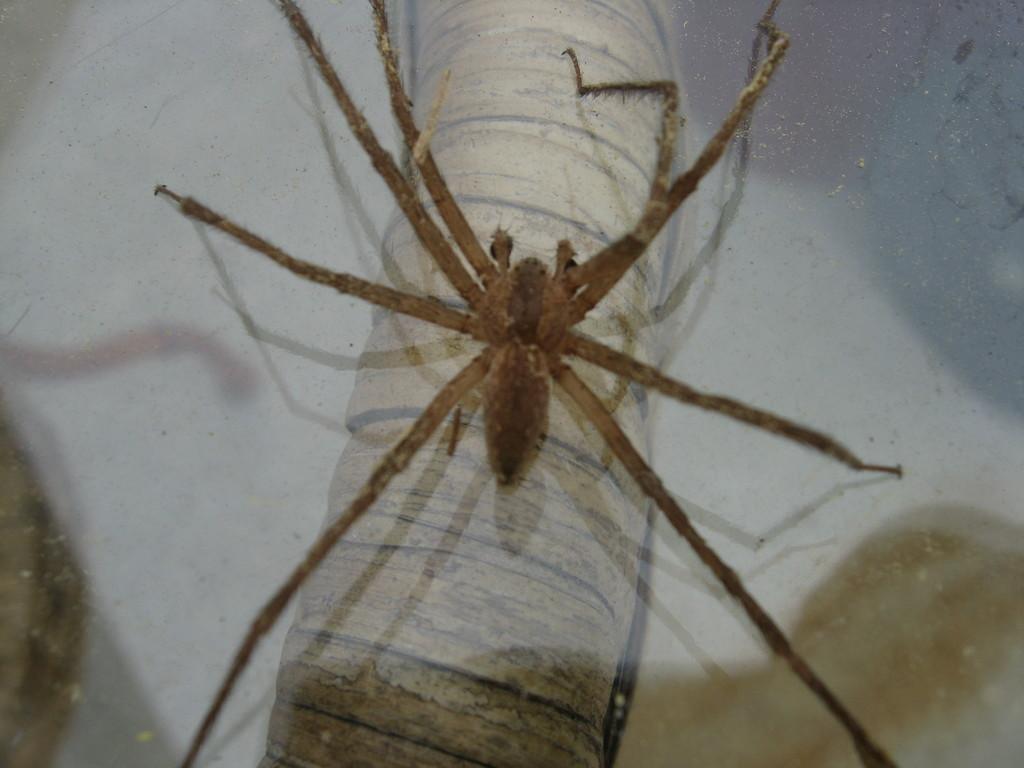Could you give a brief overview of what you see in this image? In this image, we can see a fly on the surface. 